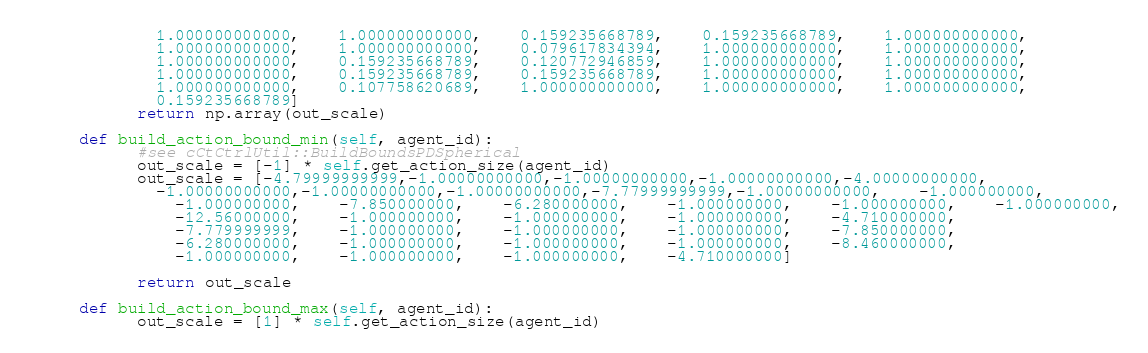<code> <loc_0><loc_0><loc_500><loc_500><_Python_>    	    1.000000000000,	1.000000000000,	0.159235668789,	0.159235668789,	1.000000000000,
    	    1.000000000000,	1.000000000000,	0.079617834394,	1.000000000000,	1.000000000000,
    	    1.000000000000,	0.159235668789,	0.120772946859,	1.000000000000,	1.000000000000,
    	    1.000000000000,	0.159235668789,	0.159235668789,	1.000000000000,	1.000000000000,
    	    1.000000000000,	0.107758620689,	1.000000000000,	1.000000000000,	1.000000000000,
    	    0.159235668789]
    	  return np.array(out_scale)
    
    def build_action_bound_min(self, agent_id):
    	  #see cCtCtrlUtil::BuildBoundsPDSpherical
    	  out_scale = [-1] * self.get_action_size(agent_id)
    	  out_scale = [-4.79999999999,-1.00000000000,-1.00000000000,-1.00000000000,-4.00000000000,
    	    -1.00000000000,-1.00000000000,-1.00000000000,-7.77999999999,-1.00000000000,	-1.000000000,
	    	  -1.000000000,	-7.850000000,	-6.280000000,	-1.000000000,	-1.000000000,	-1.000000000,
	    	  -12.56000000,	-1.000000000,	-1.000000000,	-1.000000000,	-4.710000000,
	    	  -7.779999999,	-1.000000000,	-1.000000000,	-1.000000000,	-7.850000000,
	    	  -6.280000000,	-1.000000000,	-1.000000000,	-1.000000000,	-8.460000000,
	    	  -1.000000000,	-1.000000000,	-1.000000000,	-4.710000000]

    	  return out_scale
    
    def build_action_bound_max(self, agent_id):
    	  out_scale = [1] * self.get_action_size(agent_id)</code> 